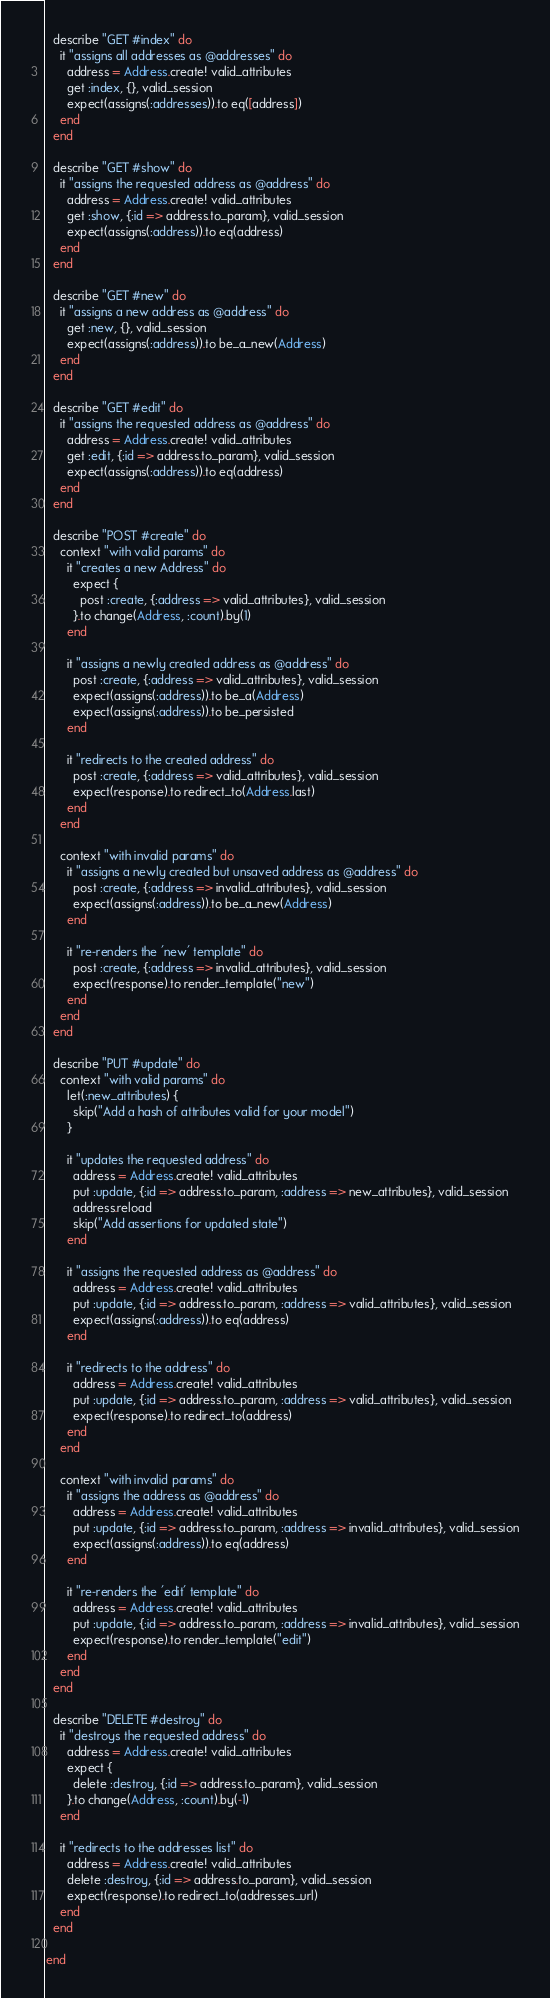Convert code to text. <code><loc_0><loc_0><loc_500><loc_500><_Ruby_>
  describe "GET #index" do
    it "assigns all addresses as @addresses" do
      address = Address.create! valid_attributes
      get :index, {}, valid_session
      expect(assigns(:addresses)).to eq([address])
    end
  end

  describe "GET #show" do
    it "assigns the requested address as @address" do
      address = Address.create! valid_attributes
      get :show, {:id => address.to_param}, valid_session
      expect(assigns(:address)).to eq(address)
    end
  end

  describe "GET #new" do
    it "assigns a new address as @address" do
      get :new, {}, valid_session
      expect(assigns(:address)).to be_a_new(Address)
    end
  end

  describe "GET #edit" do
    it "assigns the requested address as @address" do
      address = Address.create! valid_attributes
      get :edit, {:id => address.to_param}, valid_session
      expect(assigns(:address)).to eq(address)
    end
  end

  describe "POST #create" do
    context "with valid params" do
      it "creates a new Address" do
        expect {
          post :create, {:address => valid_attributes}, valid_session
        }.to change(Address, :count).by(1)
      end

      it "assigns a newly created address as @address" do
        post :create, {:address => valid_attributes}, valid_session
        expect(assigns(:address)).to be_a(Address)
        expect(assigns(:address)).to be_persisted
      end

      it "redirects to the created address" do
        post :create, {:address => valid_attributes}, valid_session
        expect(response).to redirect_to(Address.last)
      end
    end

    context "with invalid params" do
      it "assigns a newly created but unsaved address as @address" do
        post :create, {:address => invalid_attributes}, valid_session
        expect(assigns(:address)).to be_a_new(Address)
      end

      it "re-renders the 'new' template" do
        post :create, {:address => invalid_attributes}, valid_session
        expect(response).to render_template("new")
      end
    end
  end

  describe "PUT #update" do
    context "with valid params" do
      let(:new_attributes) {
        skip("Add a hash of attributes valid for your model")
      }

      it "updates the requested address" do
        address = Address.create! valid_attributes
        put :update, {:id => address.to_param, :address => new_attributes}, valid_session
        address.reload
        skip("Add assertions for updated state")
      end

      it "assigns the requested address as @address" do
        address = Address.create! valid_attributes
        put :update, {:id => address.to_param, :address => valid_attributes}, valid_session
        expect(assigns(:address)).to eq(address)
      end

      it "redirects to the address" do
        address = Address.create! valid_attributes
        put :update, {:id => address.to_param, :address => valid_attributes}, valid_session
        expect(response).to redirect_to(address)
      end
    end

    context "with invalid params" do
      it "assigns the address as @address" do
        address = Address.create! valid_attributes
        put :update, {:id => address.to_param, :address => invalid_attributes}, valid_session
        expect(assigns(:address)).to eq(address)
      end

      it "re-renders the 'edit' template" do
        address = Address.create! valid_attributes
        put :update, {:id => address.to_param, :address => invalid_attributes}, valid_session
        expect(response).to render_template("edit")
      end
    end
  end

  describe "DELETE #destroy" do
    it "destroys the requested address" do
      address = Address.create! valid_attributes
      expect {
        delete :destroy, {:id => address.to_param}, valid_session
      }.to change(Address, :count).by(-1)
    end

    it "redirects to the addresses list" do
      address = Address.create! valid_attributes
      delete :destroy, {:id => address.to_param}, valid_session
      expect(response).to redirect_to(addresses_url)
    end
  end

end
</code> 